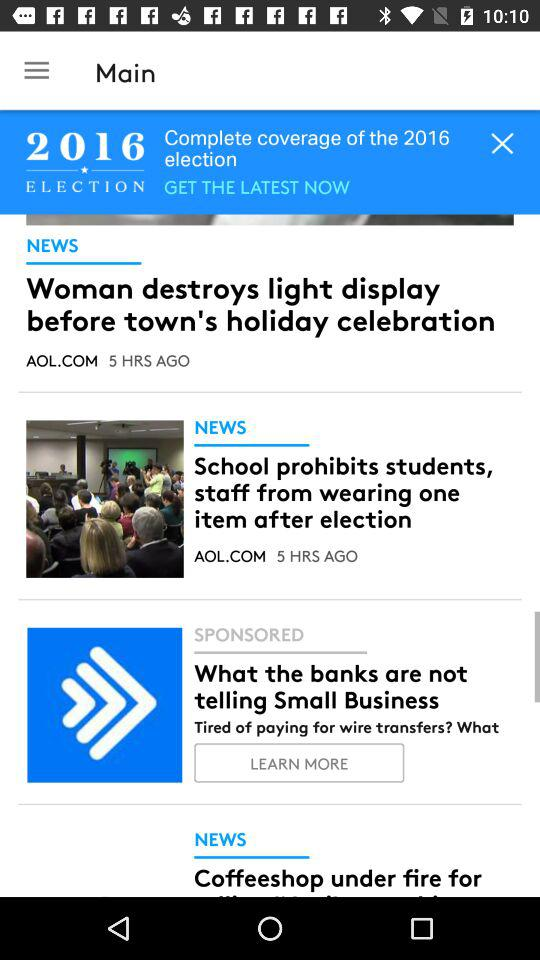How many news stories are sponsored?
Answer the question using a single word or phrase. 1 